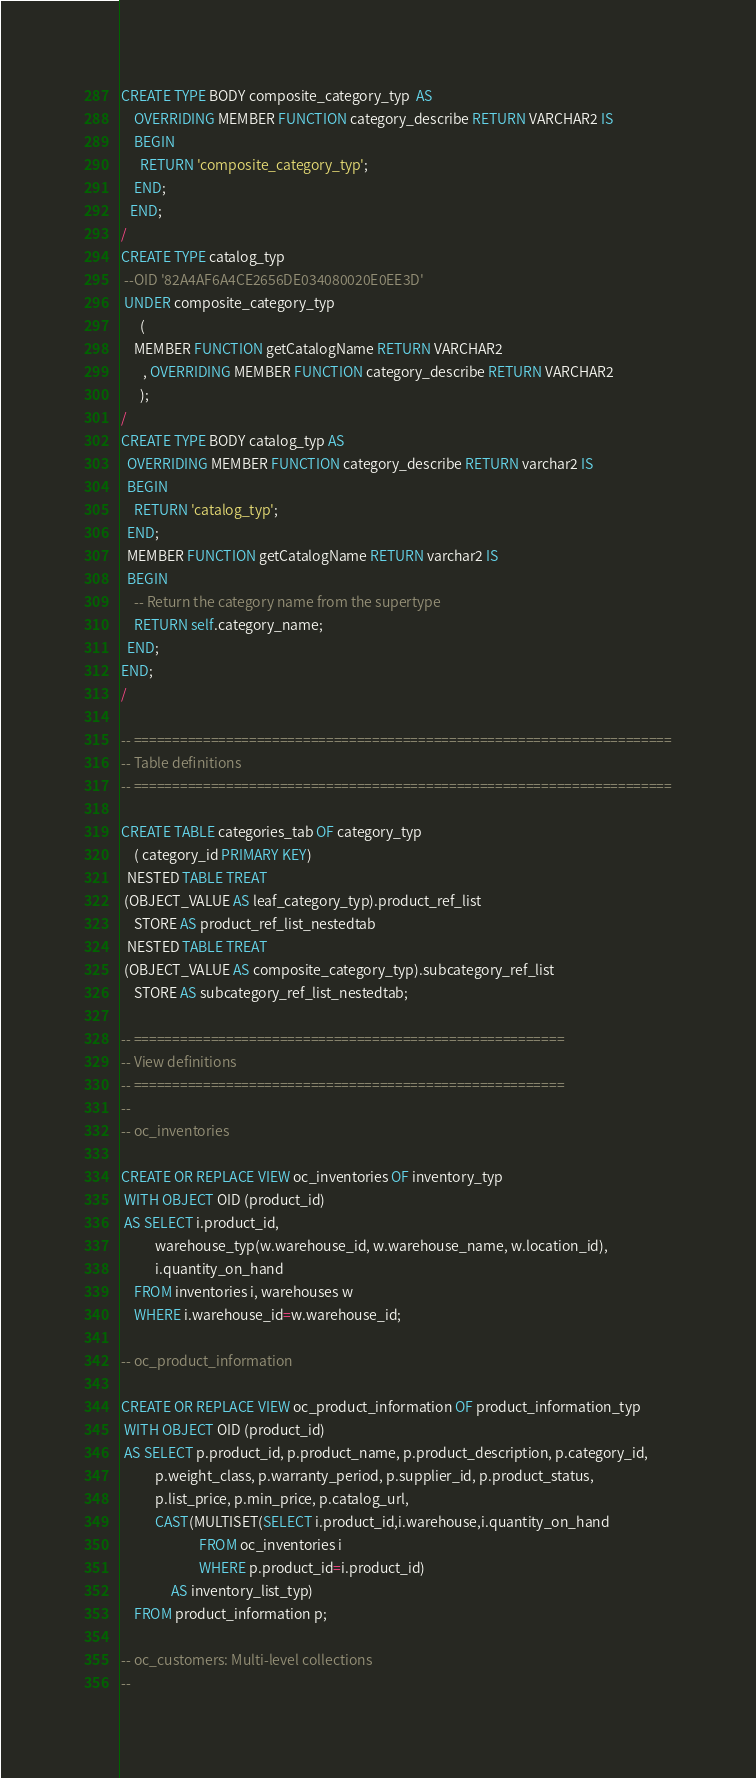Convert code to text. <code><loc_0><loc_0><loc_500><loc_500><_SQL_>CREATE TYPE BODY composite_category_typ  AS 
    OVERRIDING MEMBER FUNCTION category_describe RETURN VARCHAR2 IS 
    BEGIN 
      RETURN 'composite_category_typ'; 
    END; 
   END; 
/
CREATE TYPE catalog_typ
 --OID '82A4AF6A4CE2656DE034080020E0EE3D'
 UNDER composite_category_typ 
      ( 
    MEMBER FUNCTION getCatalogName RETURN VARCHAR2 
       , OVERRIDING MEMBER FUNCTION category_describe RETURN VARCHAR2 
      ); 
/ 
CREATE TYPE BODY catalog_typ AS
  OVERRIDING MEMBER FUNCTION category_describe RETURN varchar2 IS
  BEGIN
    RETURN 'catalog_typ';
  END;
  MEMBER FUNCTION getCatalogName RETURN varchar2 IS
  BEGIN
    -- Return the category name from the supertype
    RETURN self.category_name;
  END;
END;
/

-- ======================================================================
-- Table definitions
-- ======================================================================

CREATE TABLE categories_tab OF category_typ 
    ( category_id PRIMARY KEY)
  NESTED TABLE TREAT 
 (OBJECT_VALUE AS leaf_category_typ).product_ref_list 
    STORE AS product_ref_list_nestedtab 
  NESTED TABLE TREAT 
 (OBJECT_VALUE AS composite_category_typ).subcategory_ref_list 
    STORE AS subcategory_ref_list_nestedtab;

-- ========================================================
-- View definitions
-- ========================================================
--
-- oc_inventories

CREATE OR REPLACE VIEW oc_inventories OF inventory_typ 
 WITH OBJECT OID (product_id)
 AS SELECT i.product_id, 
           warehouse_typ(w.warehouse_id, w.warehouse_name, w.location_id),
           i.quantity_on_hand
    FROM inventories i, warehouses w
    WHERE i.warehouse_id=w.warehouse_id;

-- oc_product_information

CREATE OR REPLACE VIEW oc_product_information OF product_information_typ 
 WITH OBJECT OID (product_id)
 AS SELECT p.product_id, p.product_name, p.product_description, p.category_id,
           p.weight_class, p.warranty_period, p.supplier_id, p.product_status,
           p.list_price, p.min_price, p.catalog_url,
           CAST(MULTISET(SELECT i.product_id,i.warehouse,i.quantity_on_hand
                         FROM oc_inventories i
                         WHERE p.product_id=i.product_id)
                AS inventory_list_typ)
    FROM product_information p;

-- oc_customers: Multi-level collections
--</code> 